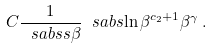<formula> <loc_0><loc_0><loc_500><loc_500>C \frac { 1 } { \ s a b s { s \beta } } \ s a b s { \ln \beta } ^ { c _ { 2 } + 1 } \beta ^ { \gamma } \, .</formula> 